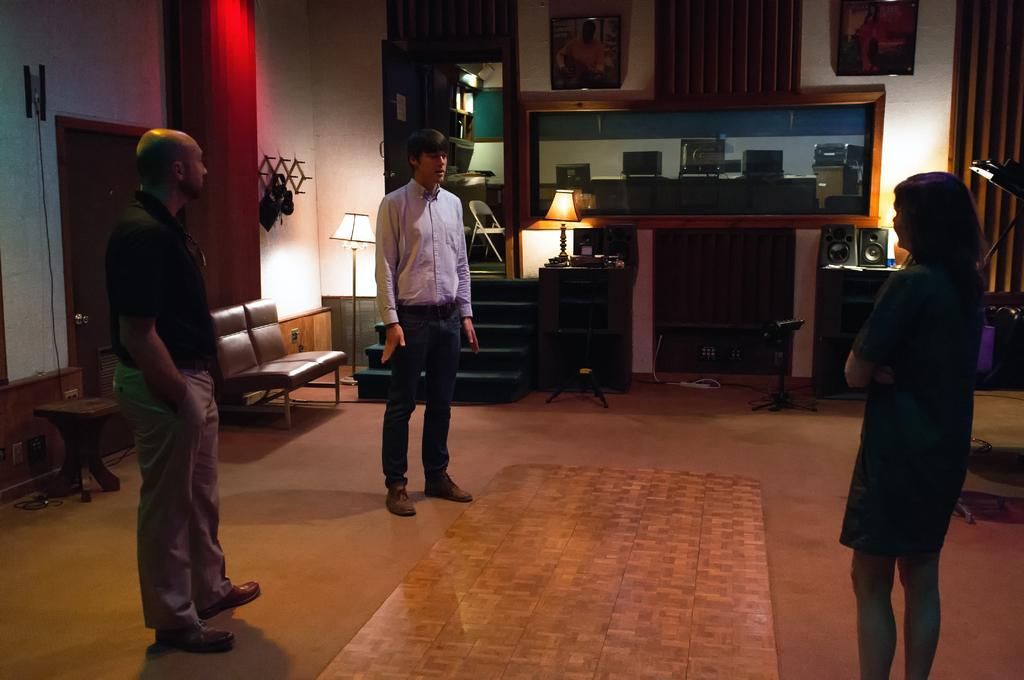What type of flooring is visible in the image? There is a floor with a carpet in the image. Who can be seen standing near the carpet? There are two men and a woman standing beside the carpet. What is located near the carpet? There is a pillar with a lamp in the image. What is near the pillar? There is a big frame near the pillar. What can be found on a table in the image? There is a sound box on a table in the image. What flavor of bomb is depicted in the image? There is no bomb present in the image, so it is not possible to determine its flavor. Is there a party happening in the image? There is no indication of a party in the image; it features a floor with a carpet, two men, a woman, a pillar with a lamp, a big frame, and a sound box on a table. 